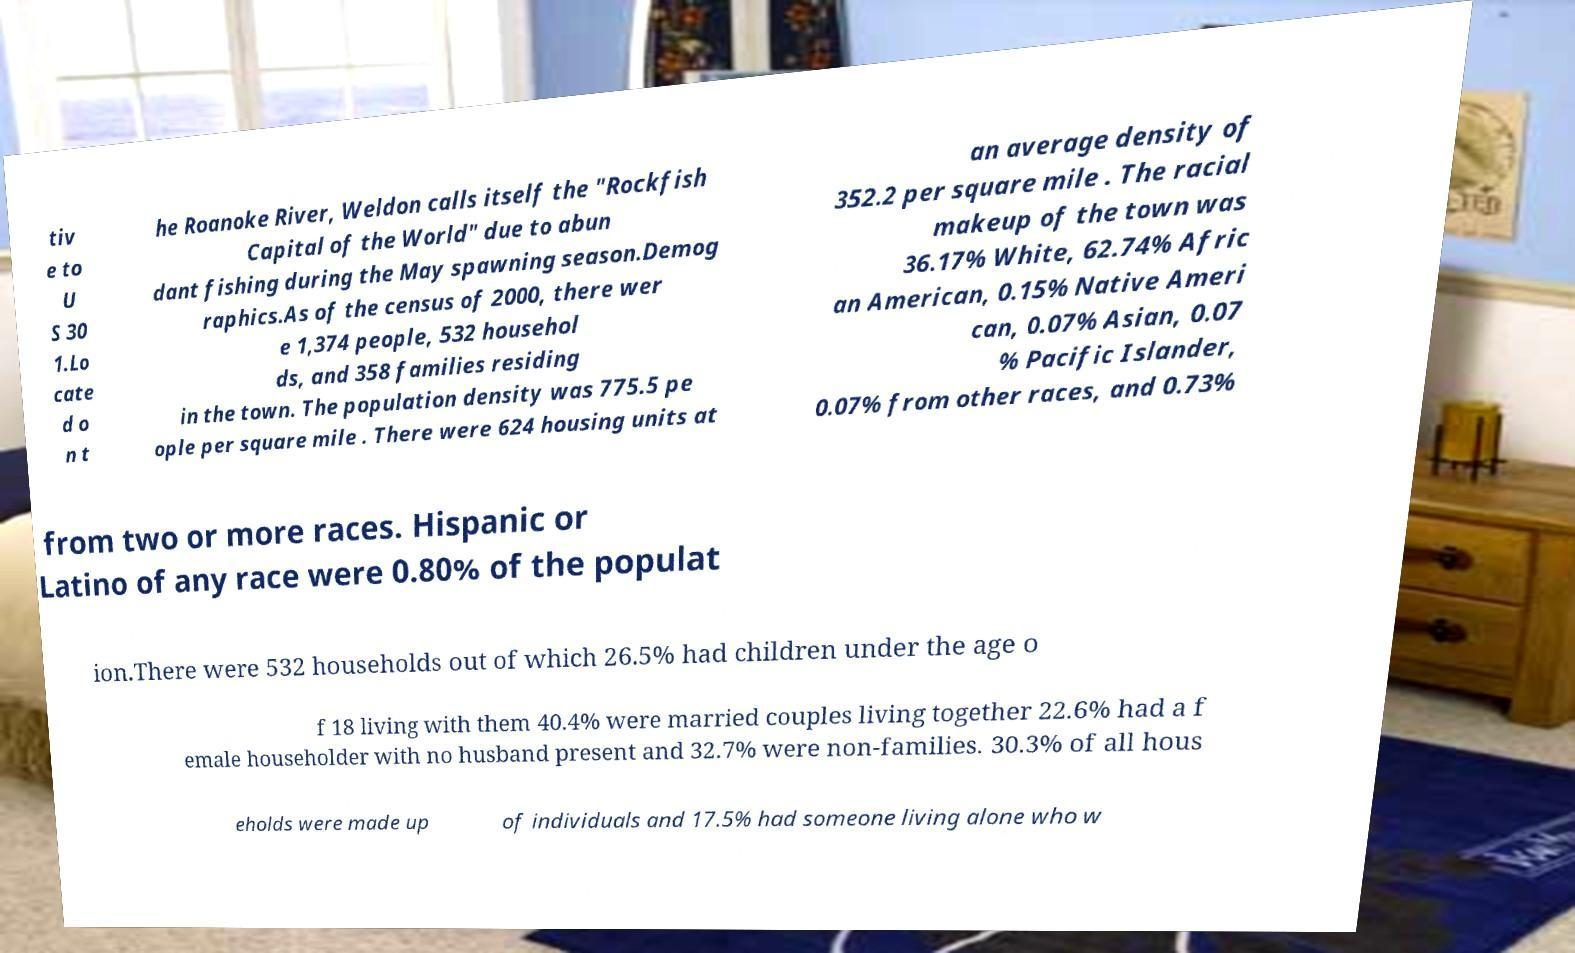What messages or text are displayed in this image? I need them in a readable, typed format. tiv e to U S 30 1.Lo cate d o n t he Roanoke River, Weldon calls itself the "Rockfish Capital of the World" due to abun dant fishing during the May spawning season.Demog raphics.As of the census of 2000, there wer e 1,374 people, 532 househol ds, and 358 families residing in the town. The population density was 775.5 pe ople per square mile . There were 624 housing units at an average density of 352.2 per square mile . The racial makeup of the town was 36.17% White, 62.74% Afric an American, 0.15% Native Ameri can, 0.07% Asian, 0.07 % Pacific Islander, 0.07% from other races, and 0.73% from two or more races. Hispanic or Latino of any race were 0.80% of the populat ion.There were 532 households out of which 26.5% had children under the age o f 18 living with them 40.4% were married couples living together 22.6% had a f emale householder with no husband present and 32.7% were non-families. 30.3% of all hous eholds were made up of individuals and 17.5% had someone living alone who w 